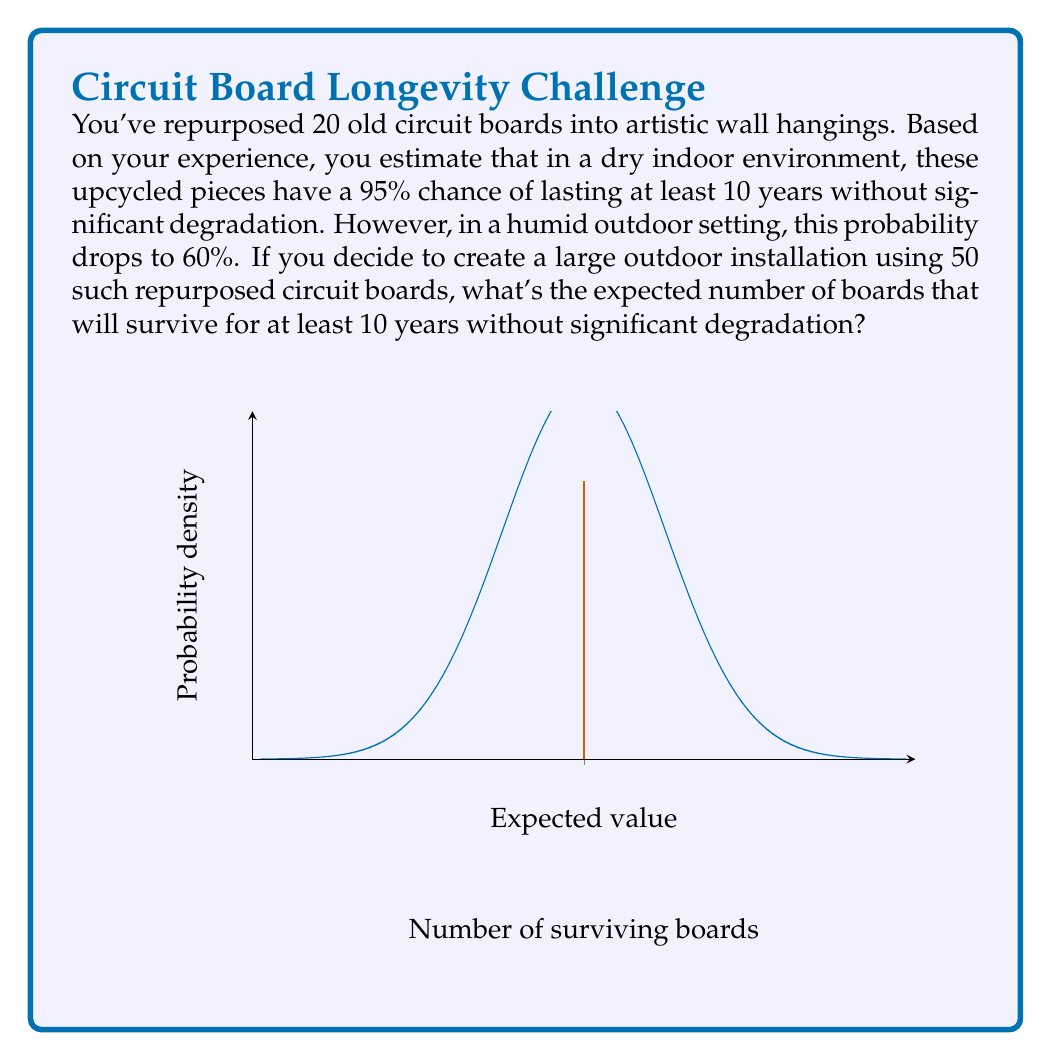Solve this math problem. Let's approach this step-by-step:

1) We're dealing with a binomial probability distribution, where each circuit board has a 60% chance of surviving for 10 years in the outdoor setting.

2) The number of trials (n) is the total number of circuit boards: 50

3) The probability of success (p) for each board is 0.60

4) In a binomial distribution, the expected value (mean) is given by the formula:

   $$E(X) = np$$

5) Substituting our values:

   $$E(X) = 50 * 0.60 = 30$$

6) To verify, we can also think about it this way:
   - Each board has a 60% chance of surviving
   - Out of 50 boards, we expect 60% of them to survive
   - 60% of 50 is 0.60 * 50 = 30

Therefore, the expected number of circuit boards that will survive for at least 10 years without significant degradation is 30.

Note: The graph in the question visualizes this binomial distribution approximated by a normal distribution (which is a good approximation for large n), with the red line indicating the expected value.
Answer: 30 circuit boards 